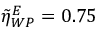<formula> <loc_0><loc_0><loc_500><loc_500>\tilde { \eta } _ { W P } ^ { E } = 0 . 7 5</formula> 